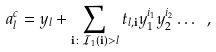<formula> <loc_0><loc_0><loc_500><loc_500>a _ { l } ^ { c } = y _ { l } + \sum _ { { \mathbf i } \colon { \mathcal { I } } _ { 1 } ( { \mathbf i } ) > l } t _ { l , { \mathbf i } } y _ { 1 } ^ { i _ { 1 } } y _ { 2 } ^ { i _ { 2 } } \dots \ ,</formula> 